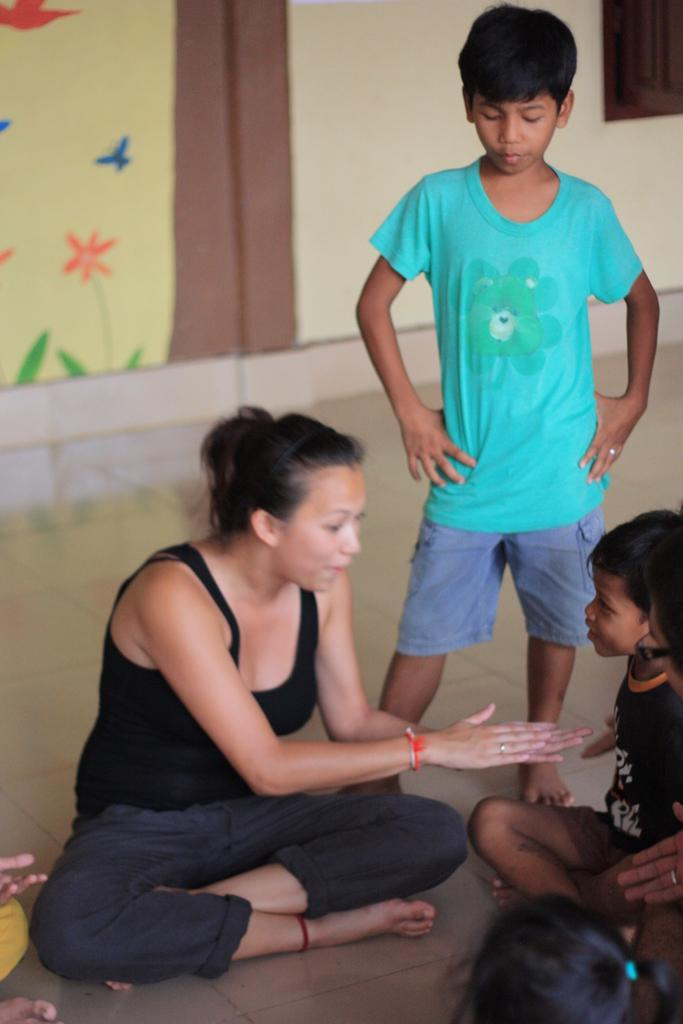How many people are in the image? There is a group of people in the image. Where are the people located in the image? The people are on the floor. What can be seen in the background of the image? There is a window and a wall with a painting on it in the background of the image. What type of record is being played by the people in the image? There is no record player or record visible in the image, so it cannot be determined if any records are being played. 